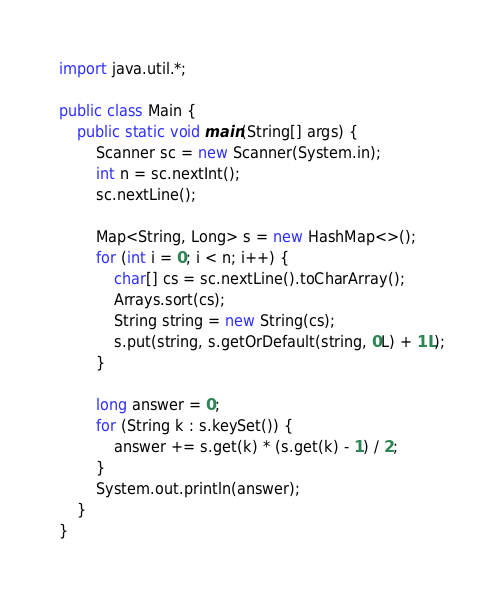<code> <loc_0><loc_0><loc_500><loc_500><_Java_>import java.util.*;

public class Main {
	public static void main(String[] args) {
		Scanner sc = new Scanner(System.in);
		int n = sc.nextInt();
		sc.nextLine();

		Map<String, Long> s = new HashMap<>();
		for (int i = 0; i < n; i++) {
			char[] cs = sc.nextLine().toCharArray();
			Arrays.sort(cs);
			String string = new String(cs);
			s.put(string, s.getOrDefault(string, 0L) + 1L);
		}

		long answer = 0;
		for (String k : s.keySet()) {
			answer += s.get(k) * (s.get(k) - 1) / 2;
		}
		System.out.println(answer);
	}
}
</code> 